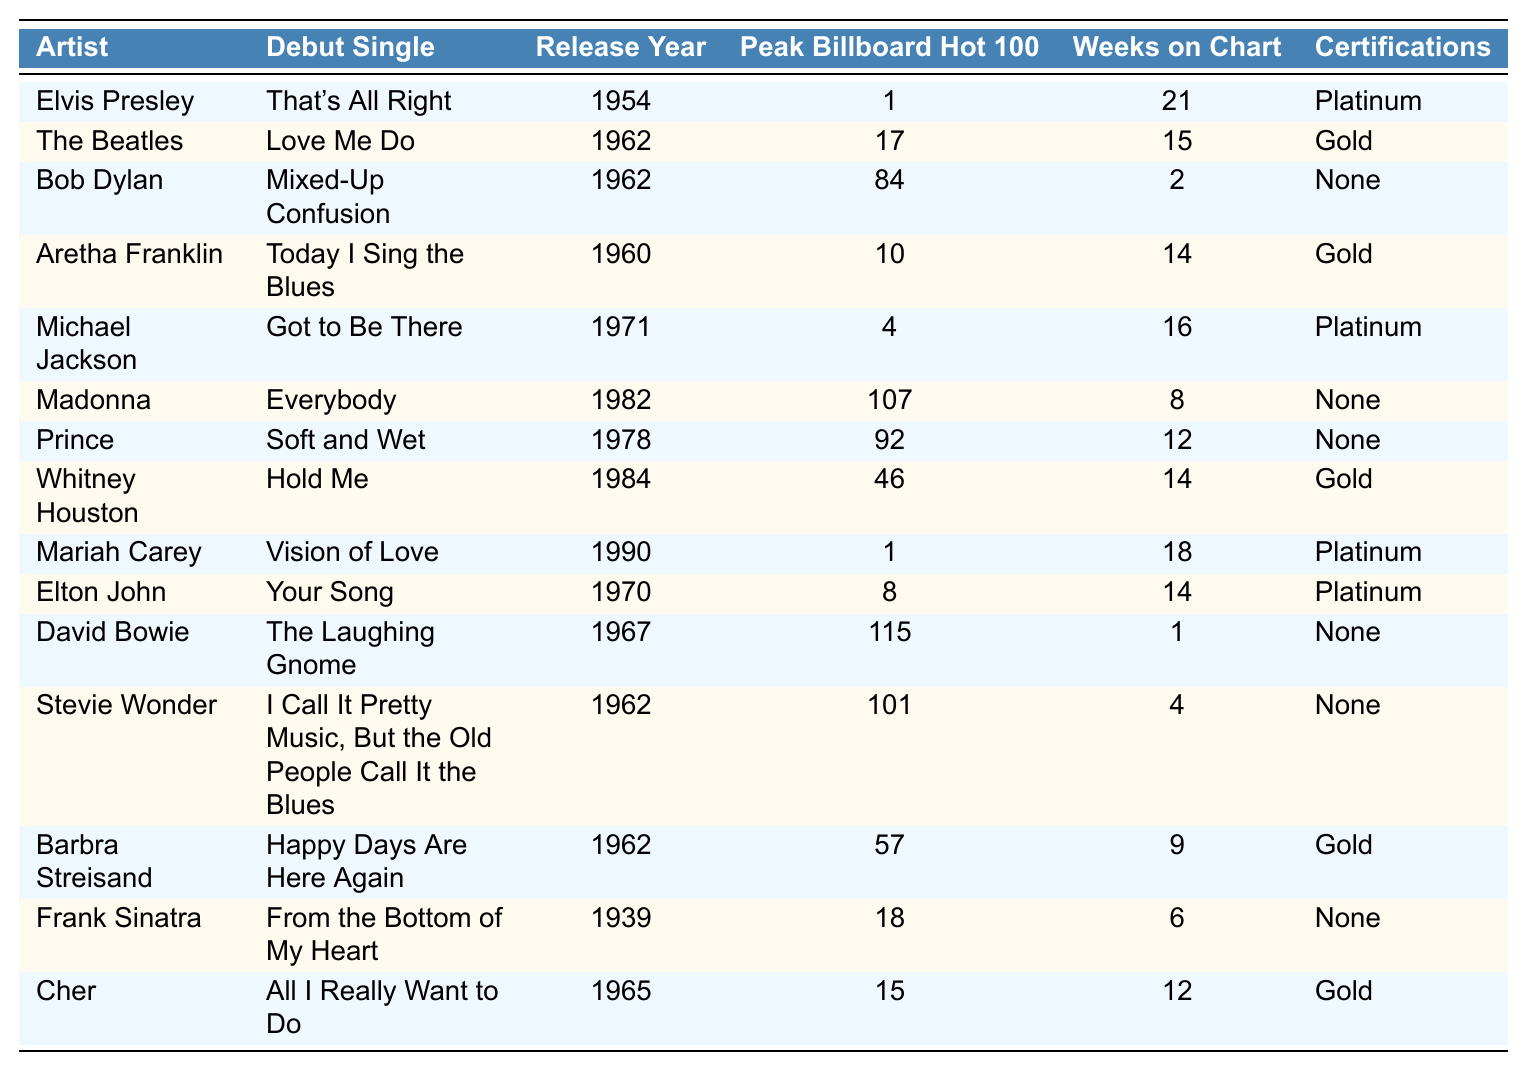What was the peak Billboard Hot 100 position of Mariah Carey's debut single? Mariah Carey's debut single, "Vision of Love," reached a peak position of 1 on the Billboard Hot 100.
Answer: 1 Which artist's debut single had the longest run on the chart? The longest run on the chart was by Elvis Presley with "That's All Right," which stayed for 21 weeks.
Answer: 21 weeks Did Bob Dylan's debut single achieve any certifications? Bob Dylan's debut single, "Mixed-Up Confusion," did not achieve any certifications as indicated in the table.
Answer: No What is the average peak position of the debut singles in the table? The peak positions are [1, 17, 84, 10, 4, 107, 92, 46, 1, 8, 115, 101, 57, 18, 15]. The sum is 1 + 17 + 84 + 10 + 4 + 107 + 92 + 46 + 1 + 8 + 115 + 101 + 57 + 18 + 15 = 696. There are 15 artists, so the average is 696 / 15 = 46.4.
Answer: 46.4 Which artist had a higher peak position: Cher or Whitney Houston? Cher's peak position is 15 and Whitney Houston's is 46. Since 15 is higher than 46, Cher had the higher peak position.
Answer: Cher How many artists debuted in the 1960s? From the table, the artists who debuted in the 1960s are The Beatles, Bob Dylan, Aretha Franklin, Barbra Streisand, and Cher, totaling 5 artists.
Answer: 5 artists What is the total number of weeks that Michael Jackson's debut single spent on the chart compared to Madonna's? Michael Jackson's debut single spent 16 weeks on the chart and Madonna's spent 8 weeks. The difference is 16 - 8 = 8 weeks, meaning Michael Jackson's single spent 8 weeks more on the chart.
Answer: 8 weeks Which artist's debut single was released in 1982, and what was its peak position? Madonna's debut single "Everybody" was released in 1982 and peaked at position 107.
Answer: 107 Is there any artist in this list whose debut single achieved a Platinum certification and reached position 1? Yes, both Elvis Presley's "That's All Right" and Mariah Carey's "Vision of Love" achieved Platinum certification and reached position 1.
Answer: Yes What is the total number of artists who received Gold certifications for their debut singles? The artists with Gold certifications are The Beatles, Aretha Franklin, Whitney Houston, Barbra Streisand, and Cher. That's a total of 5 artists.
Answer: 5 artists Which artist had a debut single with no weeks on the chart? The table shows that no artist has a debut single with zero weeks on the chart; all listed had at least 1 week.
Answer: None 